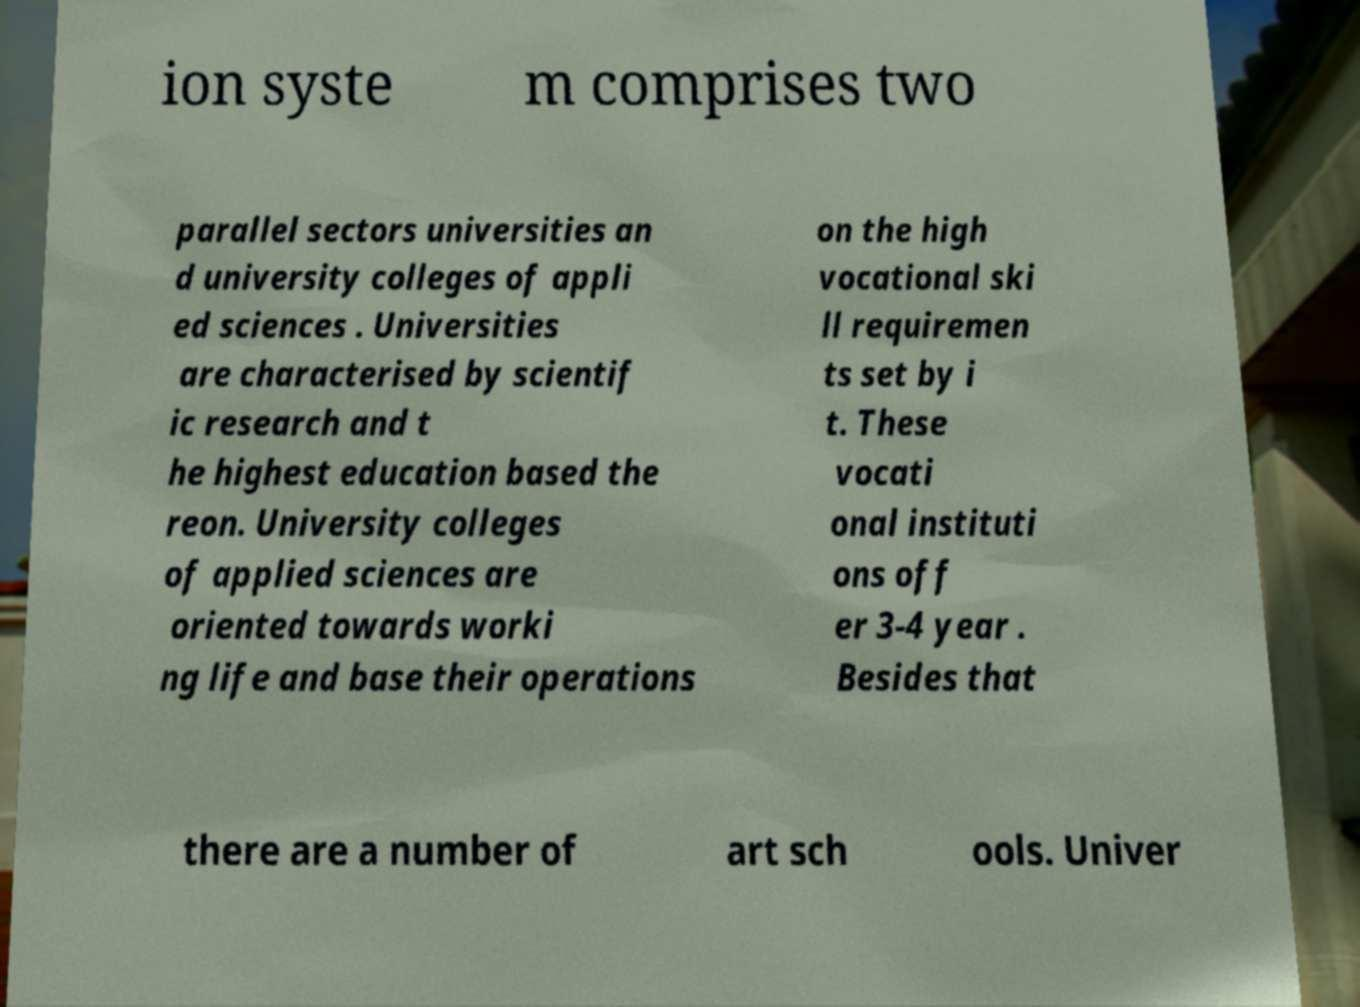I need the written content from this picture converted into text. Can you do that? ion syste m comprises two parallel sectors universities an d university colleges of appli ed sciences . Universities are characterised by scientif ic research and t he highest education based the reon. University colleges of applied sciences are oriented towards worki ng life and base their operations on the high vocational ski ll requiremen ts set by i t. These vocati onal instituti ons off er 3-4 year . Besides that there are a number of art sch ools. Univer 